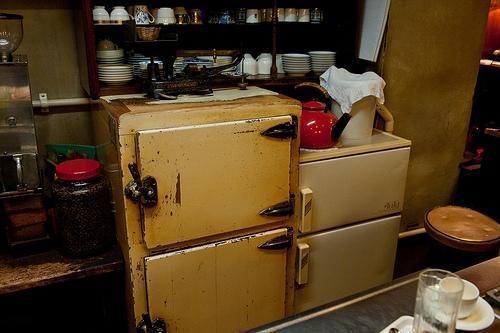How many black plates are there?
Give a very brief answer. 0. 